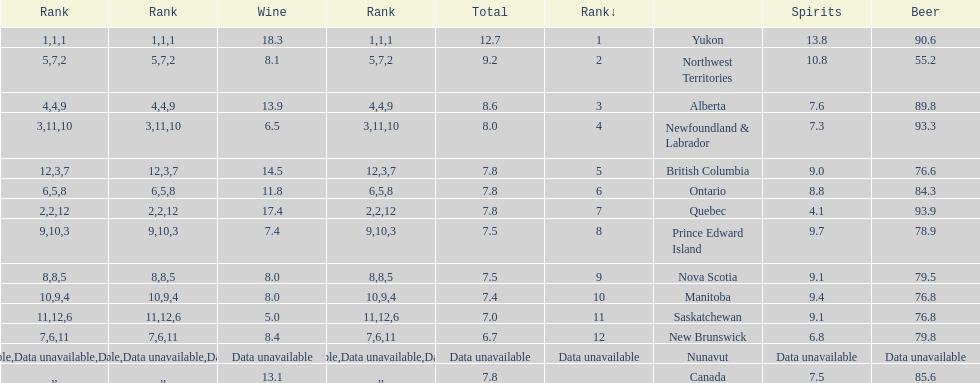How many litres do individuals in yukon consume in spirits per year? 12.7. 